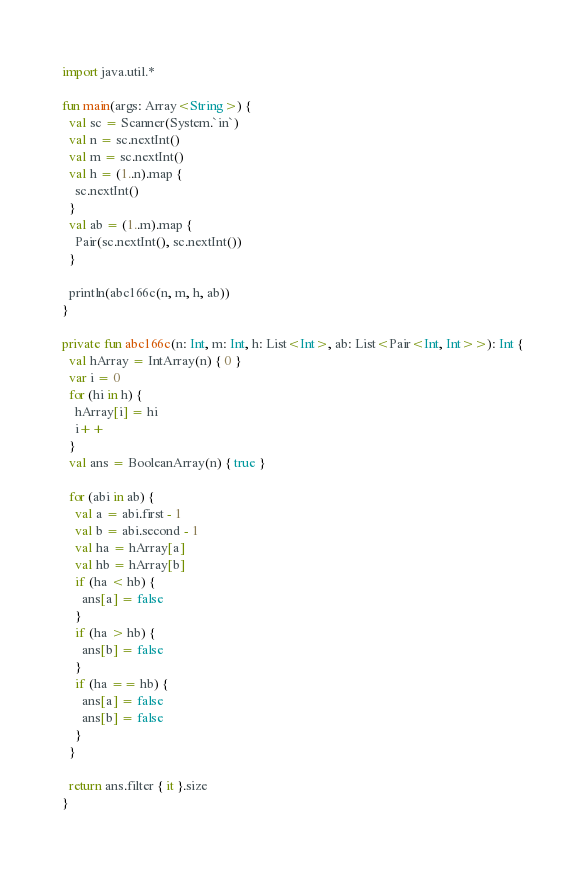<code> <loc_0><loc_0><loc_500><loc_500><_Kotlin_>import java.util.*

fun main(args: Array<String>) {
  val sc = Scanner(System.`in`)
  val n = sc.nextInt()
  val m = sc.nextInt()
  val h = (1..n).map {
    sc.nextInt()
  }
  val ab = (1..m).map {
    Pair(sc.nextInt(), sc.nextInt())
  }

  println(abc166c(n, m, h, ab))
}

private fun abc166c(n: Int, m: Int, h: List<Int>, ab: List<Pair<Int, Int>>): Int {
  val hArray = IntArray(n) { 0 }
  var i = 0
  for (hi in h) {
    hArray[i] = hi
    i++
  }
  val ans = BooleanArray(n) { true }

  for (abi in ab) {
    val a = abi.first - 1
    val b = abi.second - 1
    val ha = hArray[a]
    val hb = hArray[b]
    if (ha < hb) {
      ans[a] = false
    } 
    if (ha > hb) {
      ans[b] = false
    }
    if (ha == hb) {
      ans[a] = false
      ans[b] = false
    }
  }

  return ans.filter { it }.size
}
</code> 